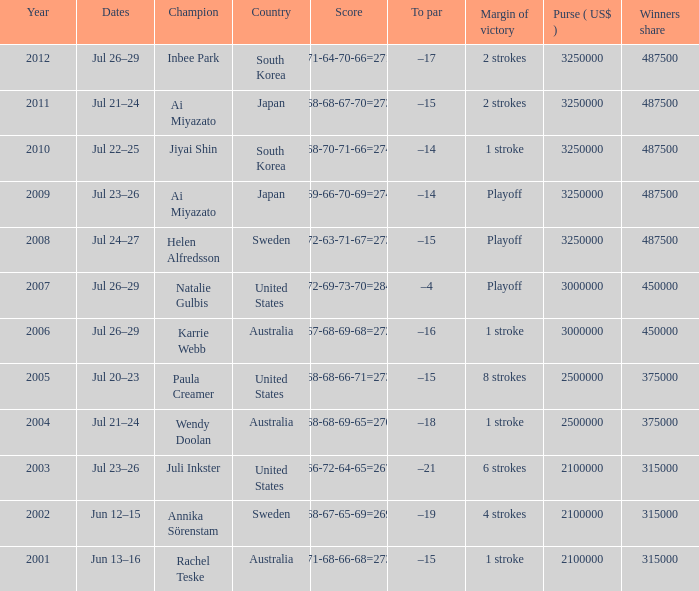What was the duration of jiyai shin's reign as champion? 1.0. 